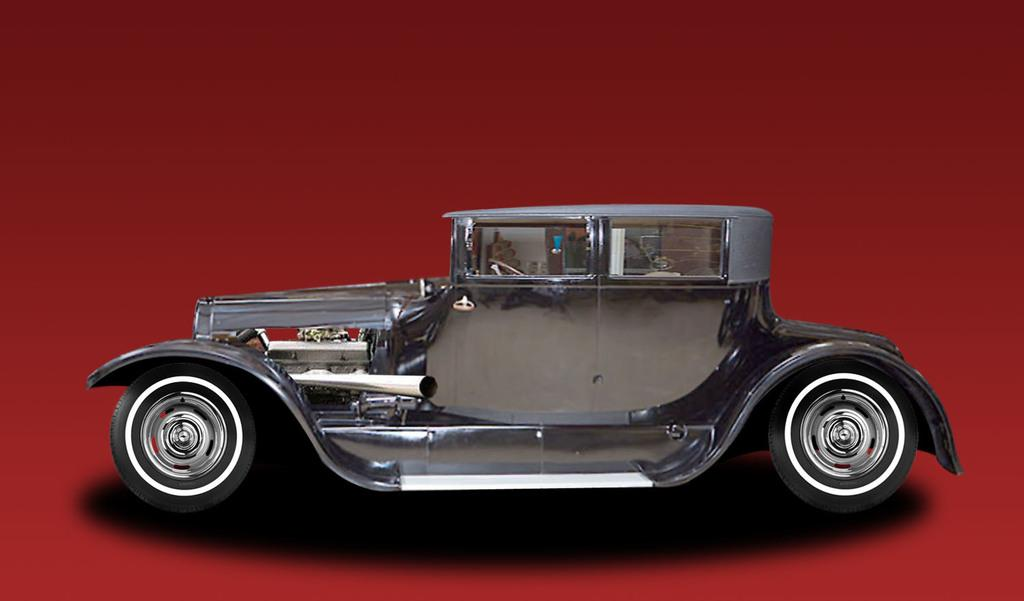What is the main subject of the image? There is a car in the image. What color is the background of the image? The background of the image is white. Can you describe the setting of the image? The image may have been taken in a hall, based on the provided fact. How many sails can be seen on the car in the image? There are no sails present on the car in the image. What type of snail is crawling on the car in the image? There are no snails present on the car in the image. 